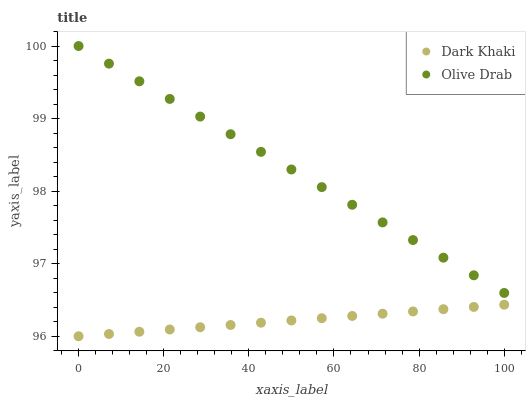Does Dark Khaki have the minimum area under the curve?
Answer yes or no. Yes. Does Olive Drab have the maximum area under the curve?
Answer yes or no. Yes. Does Olive Drab have the minimum area under the curve?
Answer yes or no. No. Is Dark Khaki the smoothest?
Answer yes or no. Yes. Is Olive Drab the roughest?
Answer yes or no. Yes. Is Olive Drab the smoothest?
Answer yes or no. No. Does Dark Khaki have the lowest value?
Answer yes or no. Yes. Does Olive Drab have the lowest value?
Answer yes or no. No. Does Olive Drab have the highest value?
Answer yes or no. Yes. Is Dark Khaki less than Olive Drab?
Answer yes or no. Yes. Is Olive Drab greater than Dark Khaki?
Answer yes or no. Yes. Does Dark Khaki intersect Olive Drab?
Answer yes or no. No. 